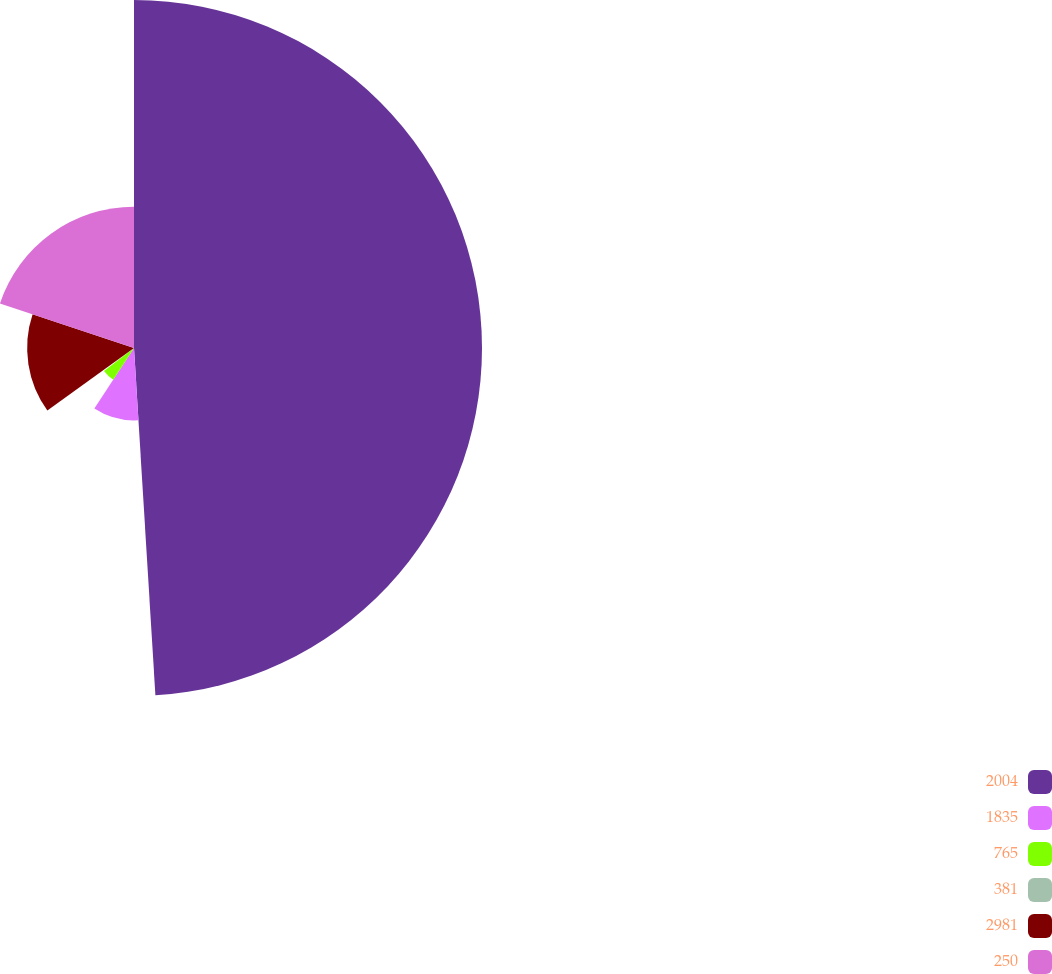Convert chart. <chart><loc_0><loc_0><loc_500><loc_500><pie_chart><fcel>2004<fcel>1835<fcel>765<fcel>381<fcel>2981<fcel>250<nl><fcel>49.02%<fcel>10.2%<fcel>5.34%<fcel>0.49%<fcel>15.05%<fcel>19.9%<nl></chart> 